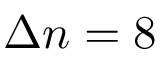<formula> <loc_0><loc_0><loc_500><loc_500>\Delta n = 8</formula> 